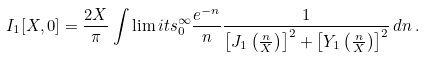<formula> <loc_0><loc_0><loc_500><loc_500>I _ { 1 } [ X , 0 ] = \frac { 2 X } { \pi } \int \lim i t s _ { 0 } ^ { \infty } \frac { e ^ { - n } } { n } \frac { 1 } { \left [ J _ { 1 } \left ( \frac { n } { X } \right ) \right ] ^ { 2 } + \left [ Y _ { 1 } \left ( \frac { n } { X } \right ) \right ] ^ { 2 } } \, d n \, .</formula> 